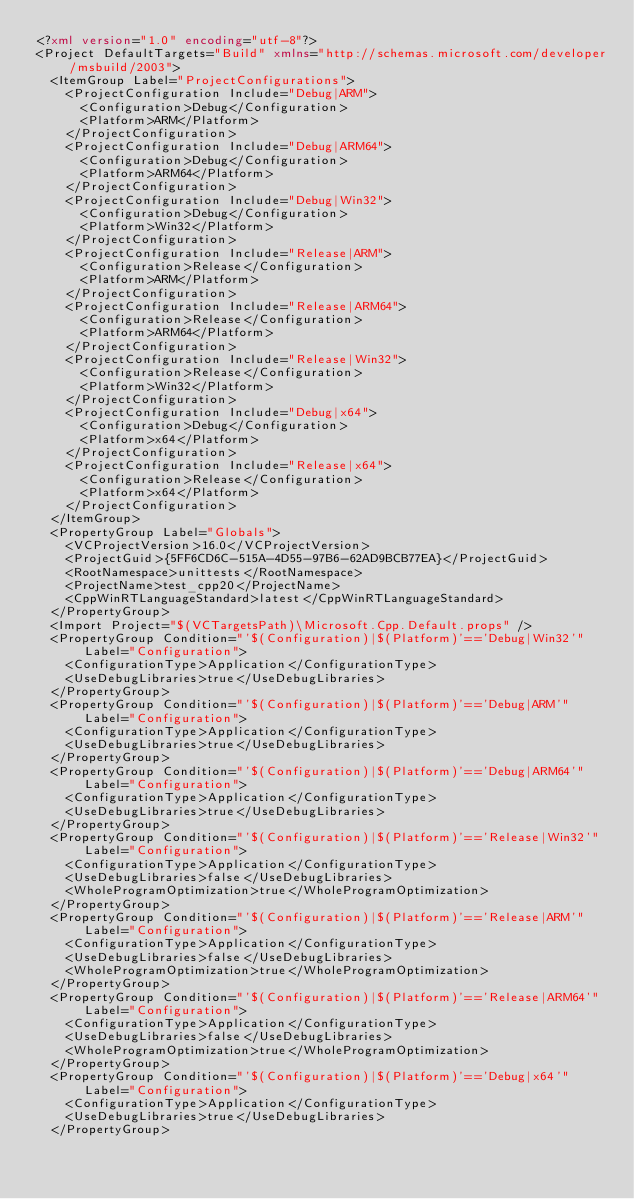Convert code to text. <code><loc_0><loc_0><loc_500><loc_500><_XML_><?xml version="1.0" encoding="utf-8"?>
<Project DefaultTargets="Build" xmlns="http://schemas.microsoft.com/developer/msbuild/2003">
  <ItemGroup Label="ProjectConfigurations">
    <ProjectConfiguration Include="Debug|ARM">
      <Configuration>Debug</Configuration>
      <Platform>ARM</Platform>
    </ProjectConfiguration>
    <ProjectConfiguration Include="Debug|ARM64">
      <Configuration>Debug</Configuration>
      <Platform>ARM64</Platform>
    </ProjectConfiguration>
    <ProjectConfiguration Include="Debug|Win32">
      <Configuration>Debug</Configuration>
      <Platform>Win32</Platform>
    </ProjectConfiguration>
    <ProjectConfiguration Include="Release|ARM">
      <Configuration>Release</Configuration>
      <Platform>ARM</Platform>
    </ProjectConfiguration>
    <ProjectConfiguration Include="Release|ARM64">
      <Configuration>Release</Configuration>
      <Platform>ARM64</Platform>
    </ProjectConfiguration>
    <ProjectConfiguration Include="Release|Win32">
      <Configuration>Release</Configuration>
      <Platform>Win32</Platform>
    </ProjectConfiguration>
    <ProjectConfiguration Include="Debug|x64">
      <Configuration>Debug</Configuration>
      <Platform>x64</Platform>
    </ProjectConfiguration>
    <ProjectConfiguration Include="Release|x64">
      <Configuration>Release</Configuration>
      <Platform>x64</Platform>
    </ProjectConfiguration>
  </ItemGroup>
  <PropertyGroup Label="Globals">
    <VCProjectVersion>16.0</VCProjectVersion>
    <ProjectGuid>{5FF6CD6C-515A-4D55-97B6-62AD9BCB77EA}</ProjectGuid>
    <RootNamespace>unittests</RootNamespace>
    <ProjectName>test_cpp20</ProjectName>
    <CppWinRTLanguageStandard>latest</CppWinRTLanguageStandard>
  </PropertyGroup>
  <Import Project="$(VCTargetsPath)\Microsoft.Cpp.Default.props" />
  <PropertyGroup Condition="'$(Configuration)|$(Platform)'=='Debug|Win32'" Label="Configuration">
    <ConfigurationType>Application</ConfigurationType>
    <UseDebugLibraries>true</UseDebugLibraries>
  </PropertyGroup>
  <PropertyGroup Condition="'$(Configuration)|$(Platform)'=='Debug|ARM'" Label="Configuration">
    <ConfigurationType>Application</ConfigurationType>
    <UseDebugLibraries>true</UseDebugLibraries>
  </PropertyGroup>
  <PropertyGroup Condition="'$(Configuration)|$(Platform)'=='Debug|ARM64'" Label="Configuration">
    <ConfigurationType>Application</ConfigurationType>
    <UseDebugLibraries>true</UseDebugLibraries>
  </PropertyGroup>
  <PropertyGroup Condition="'$(Configuration)|$(Platform)'=='Release|Win32'" Label="Configuration">
    <ConfigurationType>Application</ConfigurationType>
    <UseDebugLibraries>false</UseDebugLibraries>
    <WholeProgramOptimization>true</WholeProgramOptimization>
  </PropertyGroup>
  <PropertyGroup Condition="'$(Configuration)|$(Platform)'=='Release|ARM'" Label="Configuration">
    <ConfigurationType>Application</ConfigurationType>
    <UseDebugLibraries>false</UseDebugLibraries>
    <WholeProgramOptimization>true</WholeProgramOptimization>
  </PropertyGroup>
  <PropertyGroup Condition="'$(Configuration)|$(Platform)'=='Release|ARM64'" Label="Configuration">
    <ConfigurationType>Application</ConfigurationType>
    <UseDebugLibraries>false</UseDebugLibraries>
    <WholeProgramOptimization>true</WholeProgramOptimization>
  </PropertyGroup>
  <PropertyGroup Condition="'$(Configuration)|$(Platform)'=='Debug|x64'" Label="Configuration">
    <ConfigurationType>Application</ConfigurationType>
    <UseDebugLibraries>true</UseDebugLibraries>
  </PropertyGroup></code> 